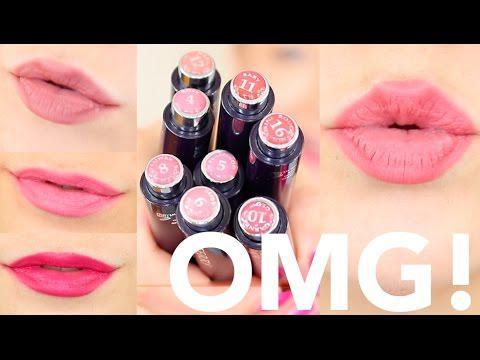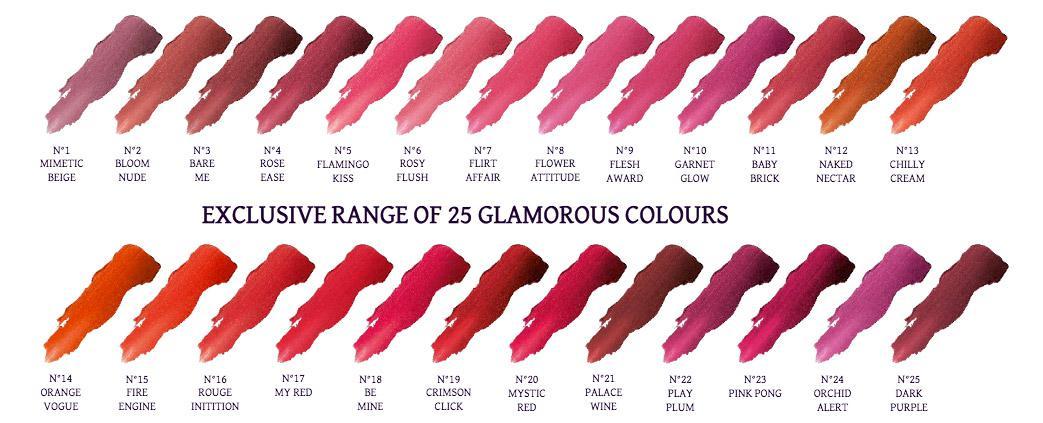The first image is the image on the left, the second image is the image on the right. For the images shown, is this caption "One of the images shows different shades of lipstick on human arm." true? Answer yes or no. No. The first image is the image on the left, the second image is the image on the right. Examine the images to the left and right. Is the description "An image shows smears of lipstick across at least one inner arm." accurate? Answer yes or no. No. 